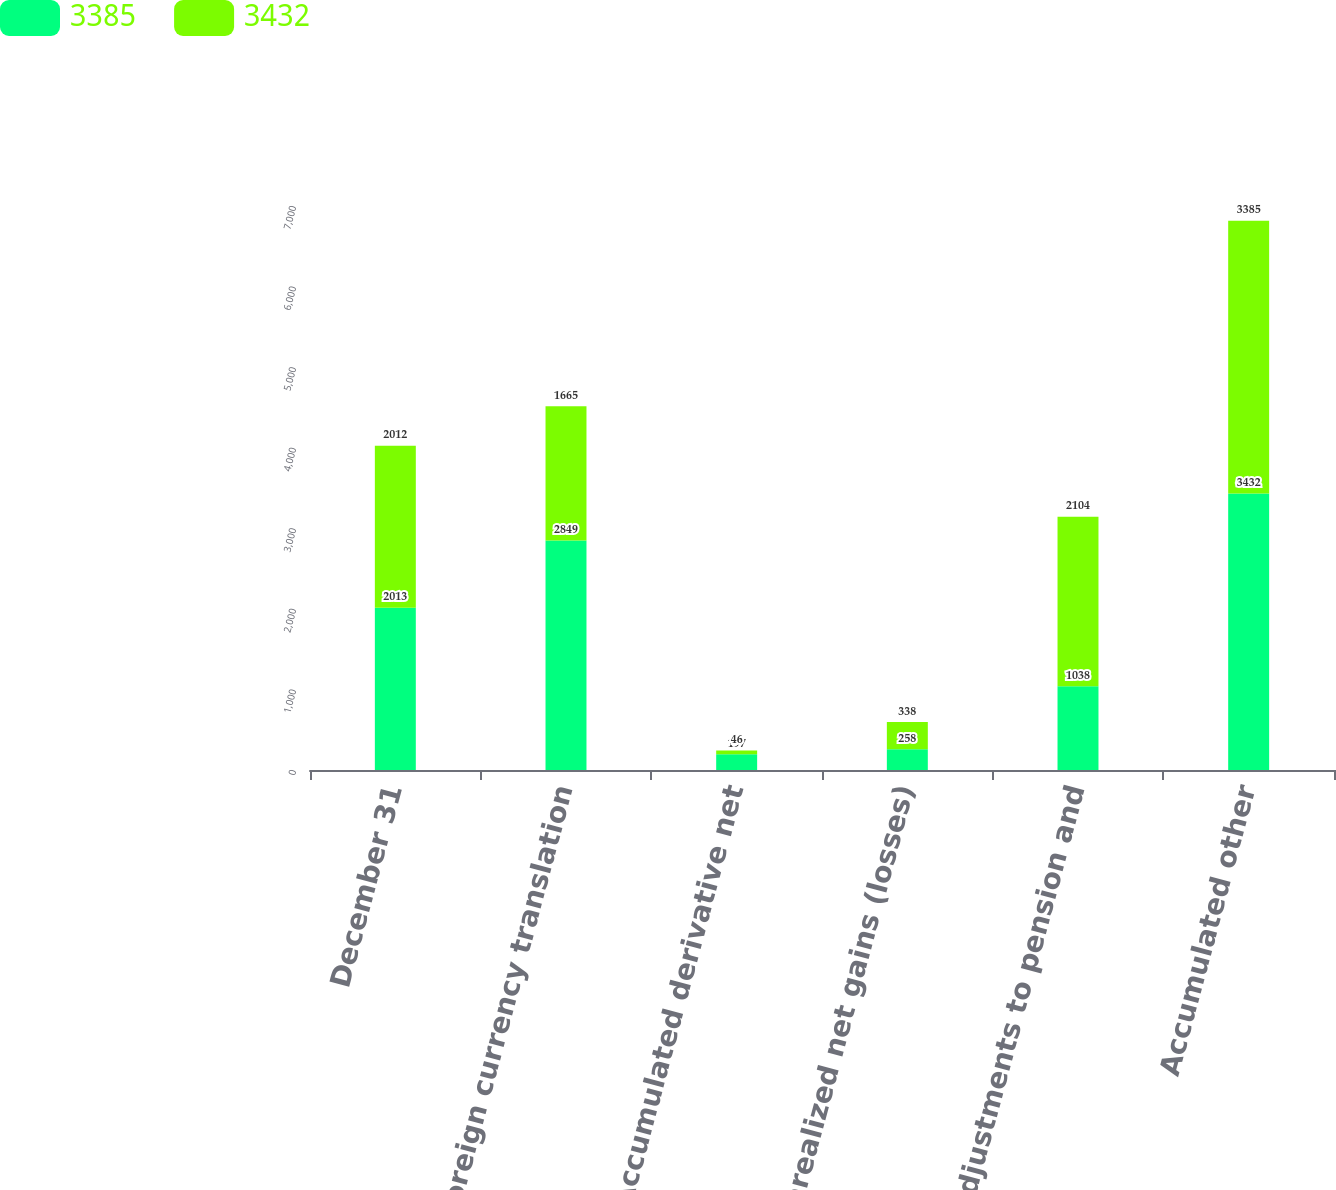<chart> <loc_0><loc_0><loc_500><loc_500><stacked_bar_chart><ecel><fcel>December 31<fcel>Foreign currency translation<fcel>Accumulated derivative net<fcel>Unrealized net gains (losses)<fcel>Adjustments to pension and<fcel>Accumulated other<nl><fcel>3385<fcel>2013<fcel>2849<fcel>197<fcel>258<fcel>1038<fcel>3432<nl><fcel>3432<fcel>2012<fcel>1665<fcel>46<fcel>338<fcel>2104<fcel>3385<nl></chart> 